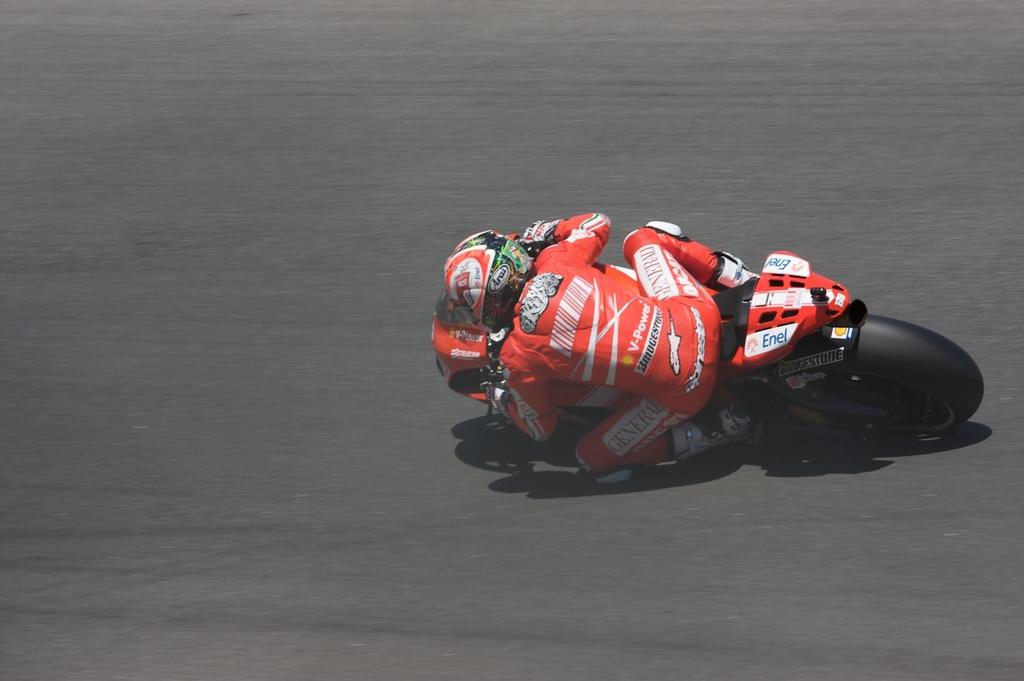Who is present in the image? There is a man in the image. What is the man wearing on his head? The man is wearing a helmet. What type of clothing is the man wearing on his upper body? The man is wearing a t-shirt. What type of hand protection is the man wearing? The man is wearing gloves. What type of clothing is the man wearing on his lower body? The man is wearing trousers. What type of footwear is the man wearing? The man is wearing shoes. What is the man doing in the image? The man is riding a bike. Where is the bike located in the image? The bike is on the road. What type of cheese can be seen in the image? There is no cheese present in the image. How does the fog affect the visibility of the man and the bike in the image? There is no fog present in the image, so its effect on visibility cannot be determined. 